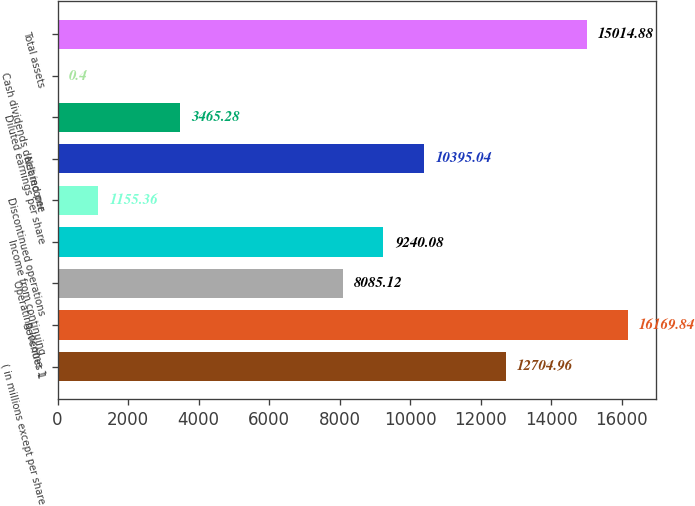<chart> <loc_0><loc_0><loc_500><loc_500><bar_chart><fcel>( in millions except per share<fcel>Revenues 1<fcel>Operating income 1<fcel>Income from continuing<fcel>Discontinued operations<fcel>Net income<fcel>Diluted earnings per share<fcel>Cash dividends declared per<fcel>Total assets<nl><fcel>12705<fcel>16169.8<fcel>8085.12<fcel>9240.08<fcel>1155.36<fcel>10395<fcel>3465.28<fcel>0.4<fcel>15014.9<nl></chart> 